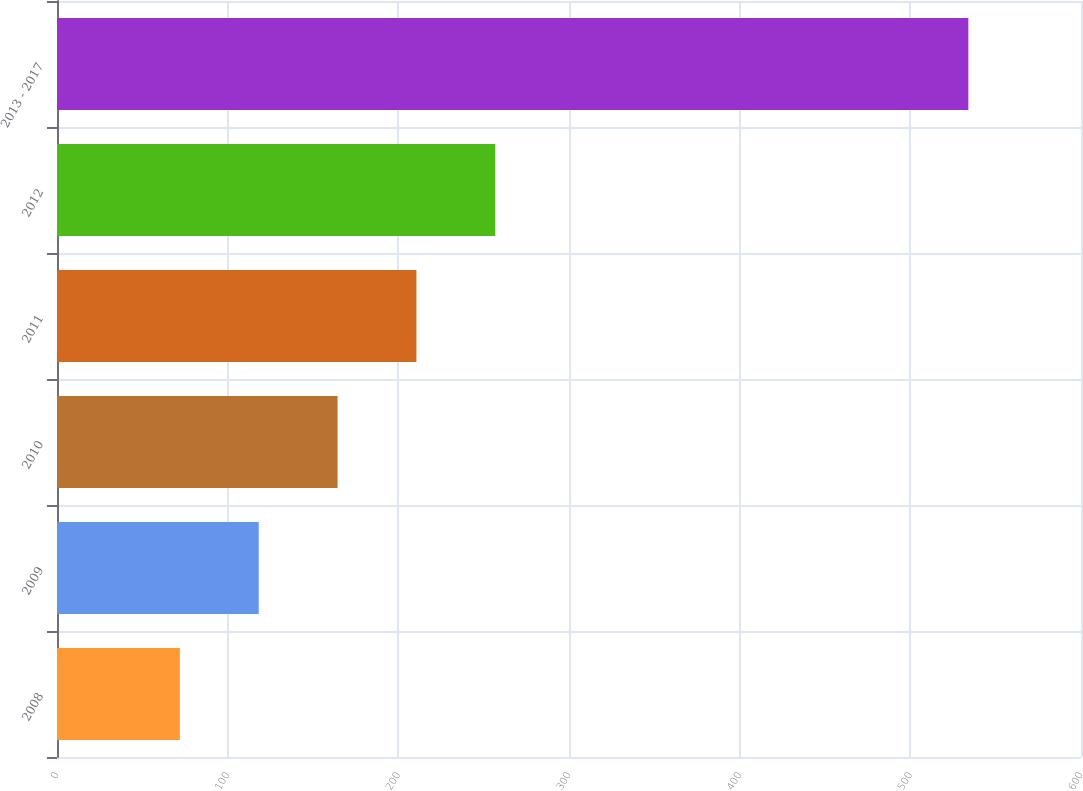<chart> <loc_0><loc_0><loc_500><loc_500><bar_chart><fcel>2008<fcel>2009<fcel>2010<fcel>2011<fcel>2012<fcel>2013 - 2017<nl><fcel>72<fcel>118.2<fcel>164.4<fcel>210.6<fcel>256.8<fcel>534<nl></chart> 